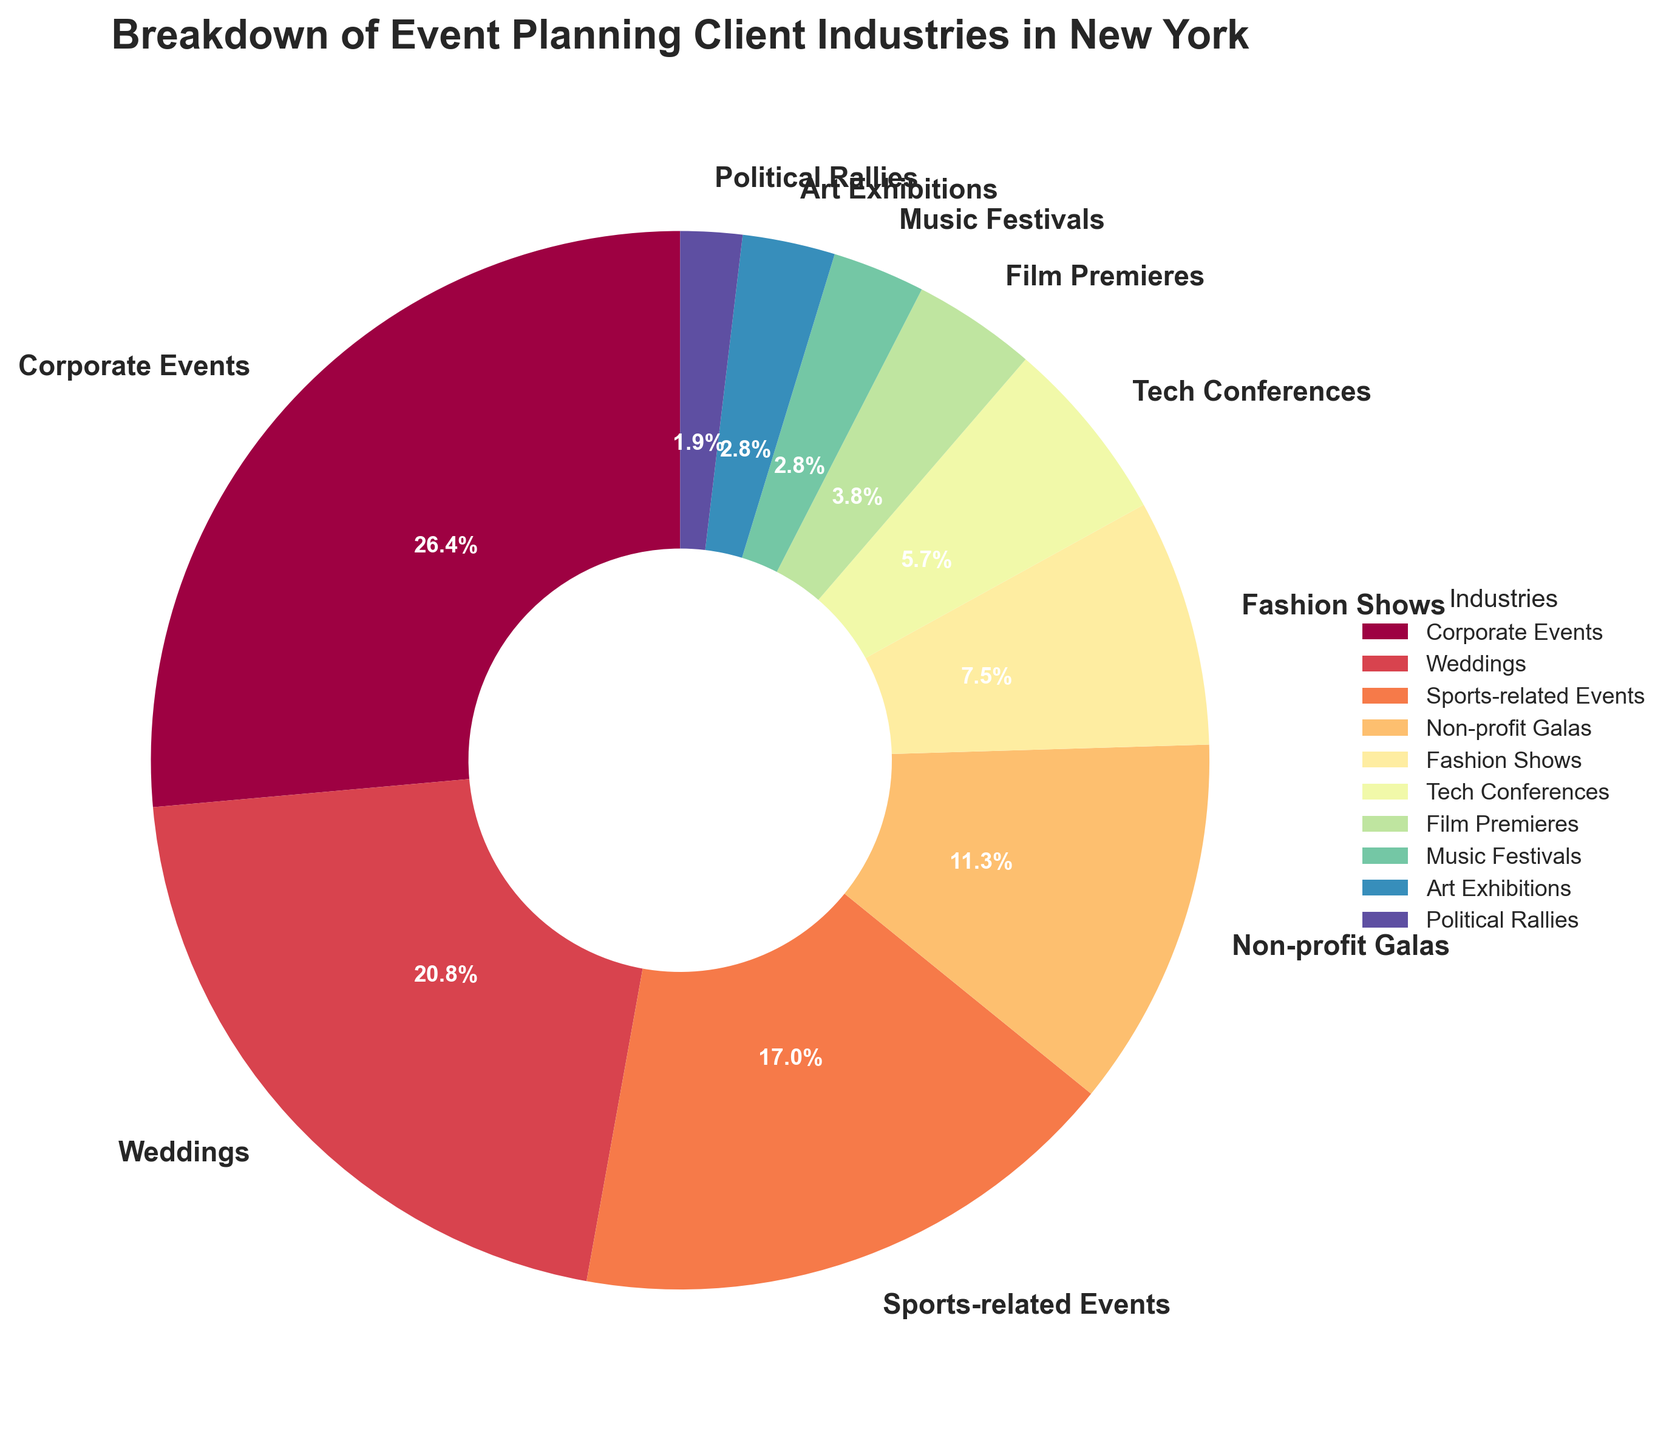What is the largest segment in the pie chart? Looking at the pie chart, the largest segment is labeled "Corporate Events" with a percentage of 28%.
Answer: Corporate Events Which industry has a higher percentage, Non-profit Galas or Tech Conferences? By observing the pie chart, Non-profit Galas have a percentage of 12%, whereas Tech Conferences have a percentage of 6%. Since 12% is greater than 6%, Non-profit Galas have the higher percentage.
Answer: Non-profit Galas How many industry segments individually represent 3% of the total? The pie chart shows that Music Festivals and Art Exhibitions both have 3%. Thus, there are 2 industry segments that represent 3% each.
Answer: 2 What is the total percentage of Weddings and Sports-related Events combined? Weddings contribute 22% and Sports-related Events contribute 18%. Adding these together, 22% + 18% = 40%.
Answer: 40% Is the percentage of Political Rallies greater than Fashion Shows? The pie chart shows that Political Rallies have a percentage of 2%, while Fashion Shows have a percentage of 8%. Since 2% is less than 8%, Political Rallies have a smaller percentage.
Answer: No What is the sum of the percentages for the smallest three segments in the pie chart? The smallest three segments are Political Rallies (2%), Music Festivals (3%), and Art Exhibitions (3%). Adding these together, 2% + 3% + 3% = 8%.
Answer: 8% Which industry segment is represented by a color closest to red in the pie chart? By looking at the color scheme of the pie chart using the designated colormap (Spectral), the segment for Corporate Events appears to be the one closest to red.
Answer: Corporate Events What percentage of the total do Fashion Shows and Tech Conferences together represent? Fashion Shows have 8% and Tech Conferences have 6%. Adding these, 8% + 6% = 14%.
Answer: 14% Which industry has the third-largest percentage in the chart, and what is that percentage? The top three industries are Corporate Events (28%), Weddings (22%), and Sports-related Events (18%). So, the third-largest is Sports-related Events with 18%.
Answer: Sports-related Events, 18% What percentage more do Corporate Events have compared to Weddings? Corporate Events have 28%, and Weddings have 22%. The difference is 28% - 22% = 6%.
Answer: 6% 